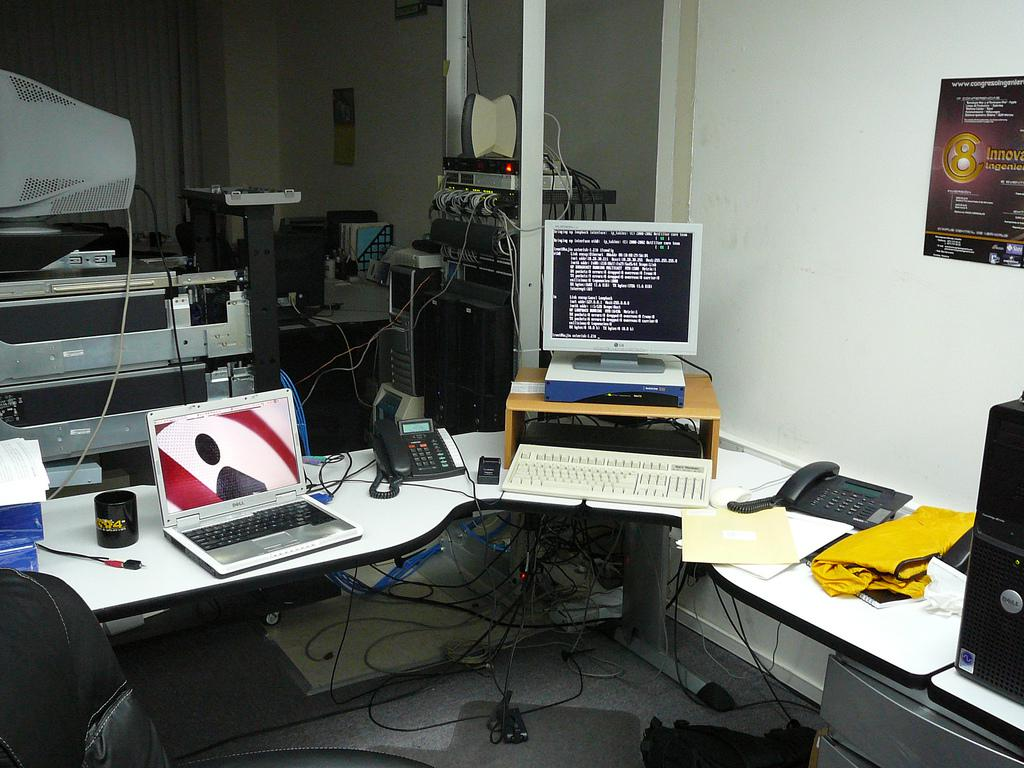Question: how many computers are there?
Choices:
A. Two.
B. One.
C. Three.
D. Four.
Answer with the letter. Answer: A Question: where is this scene?
Choices:
A. A Park.
B. A House.
C. A warehouse.
D. An office.
Answer with the letter. Answer: D Question: who is there?
Choices:
A. Everyone.
B. Bob.
C. Tom.
D. No one.
Answer with the letter. Answer: D Question: what is on the desk?
Choices:
A. Computers.
B. Pictures.
C. Keyboards.
D. Mice.
Answer with the letter. Answer: A Question: what color is the wall?
Choices:
A. Black.
B. White.
C. Blue.
D. Red.
Answer with the letter. Answer: B Question: where is scene occuring?
Choices:
A. In a kitchen.
B. In a office.
C. In a bathroom.
D. In a bedroom.
Answer with the letter. Answer: B Question: what wall is the poster on?
Choices:
A. The right wall.
B. The left wall.
C. The front wall.
D. The back wall.
Answer with the letter. Answer: A Question: what is on the shelf?
Choices:
A. The mug.
B. The keys.
C. The plate.
D. The computer.
Answer with the letter. Answer: D Question: where are the phones?
Choices:
A. On the counter.
B. In the student's hands.
C. In an airport.
D. On the desk.
Answer with the letter. Answer: D Question: where are the cords?
Choices:
A. In the drawer.
B. Attached to the TV.
C. Overhead.
D. Under the desk.
Answer with the letter. Answer: D Question: where is this scene?
Choices:
A. In the living room.
B. In the kitchen.
C. In the  bathroom.
D. In an office.
Answer with the letter. Answer: D Question: what colors are the phones?
Choices:
A. Black.
B. White.
C. Grey.
D. Navy blue.
Answer with the letter. Answer: C Question: how many coffee mugs are on the desk?
Choices:
A. Two.
B. One.
C. Three.
D. Four.
Answer with the letter. Answer: B Question: what is the laptop made of?
Choices:
A. Metal.
B. Plastic.
C. Aluminum.
D. .Glassl.
Answer with the letter. Answer: A Question: what color is the laptop screen?
Choices:
A. Gray.
B. Blue, green, and brown.
C. Purple, orange, and green.
D. Red black and white.
Answer with the letter. Answer: D Question: what is the computer stand made of?
Choices:
A. Plastic.
B. Wood.
C. Glass.
D. Metal.
Answer with the letter. Answer: B Question: where is the room more lit?
Choices:
A. Around table.
B. Around bed.
C. Around dresser.
D. Around desk.
Answer with the letter. Answer: D Question: what is on the black computer screen?
Choices:
A. Nothing.
B. Dust.
C. Data.
D. Programs.
Answer with the letter. Answer: C 